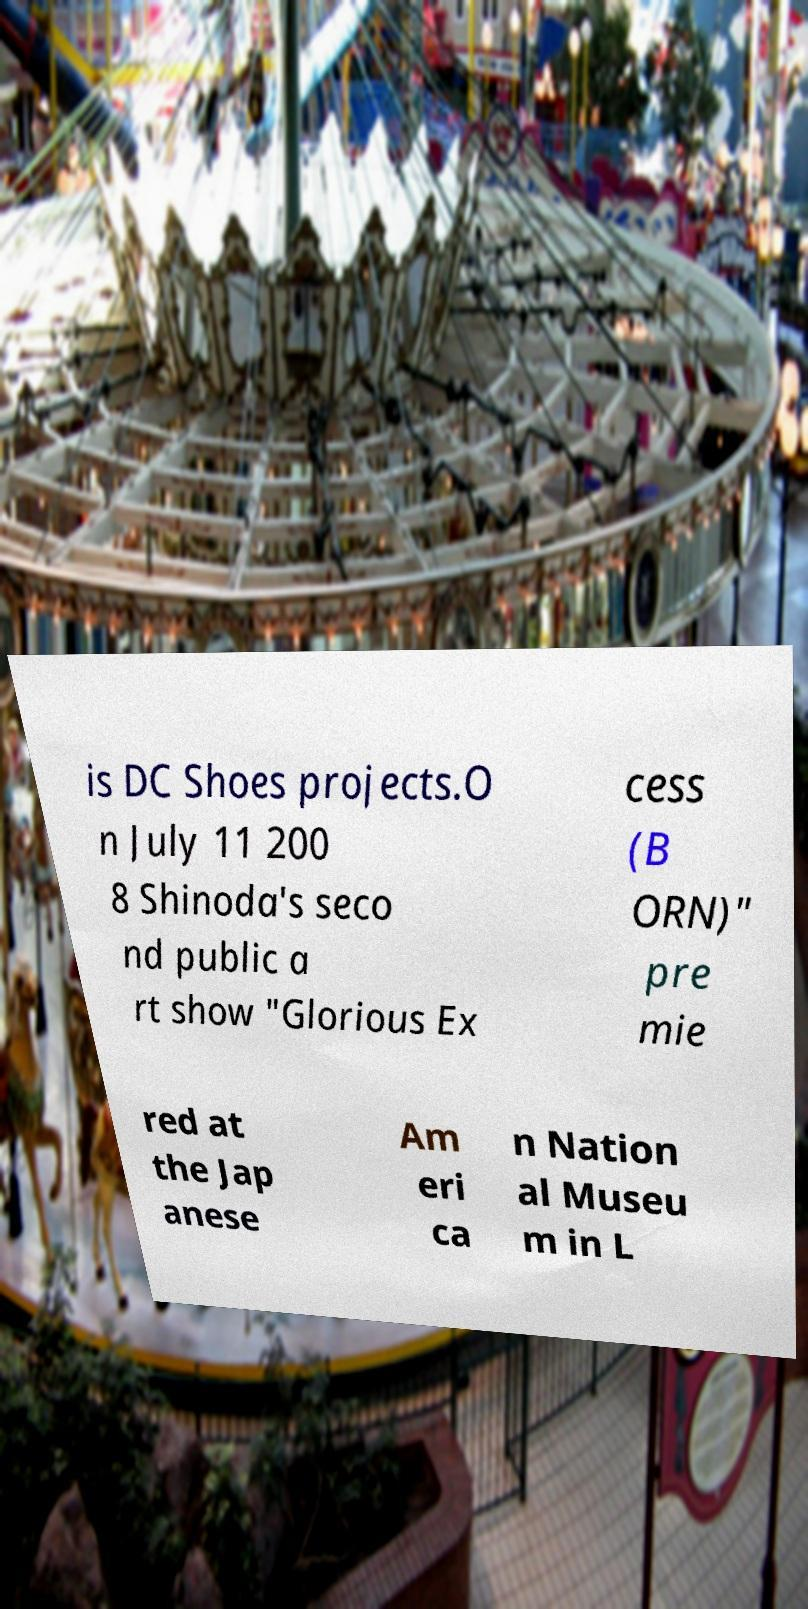Please identify and transcribe the text found in this image. is DC Shoes projects.O n July 11 200 8 Shinoda's seco nd public a rt show "Glorious Ex cess (B ORN)" pre mie red at the Jap anese Am eri ca n Nation al Museu m in L 